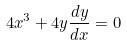<formula> <loc_0><loc_0><loc_500><loc_500>4 x ^ { 3 } + 4 y \frac { d y } { d x } = 0</formula> 